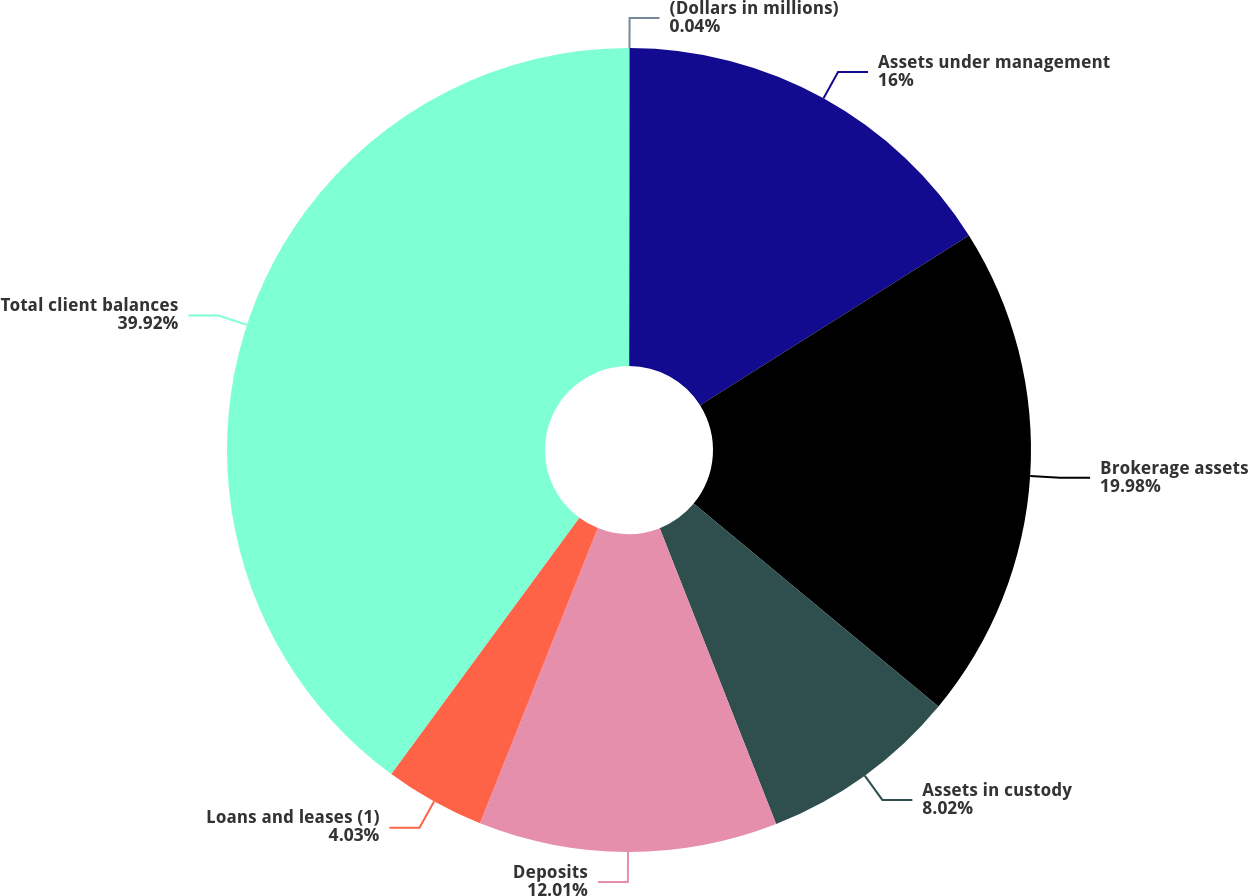Convert chart. <chart><loc_0><loc_0><loc_500><loc_500><pie_chart><fcel>(Dollars in millions)<fcel>Assets under management<fcel>Brokerage assets<fcel>Assets in custody<fcel>Deposits<fcel>Loans and leases (1)<fcel>Total client balances<nl><fcel>0.04%<fcel>16.0%<fcel>19.98%<fcel>8.02%<fcel>12.01%<fcel>4.03%<fcel>39.93%<nl></chart> 